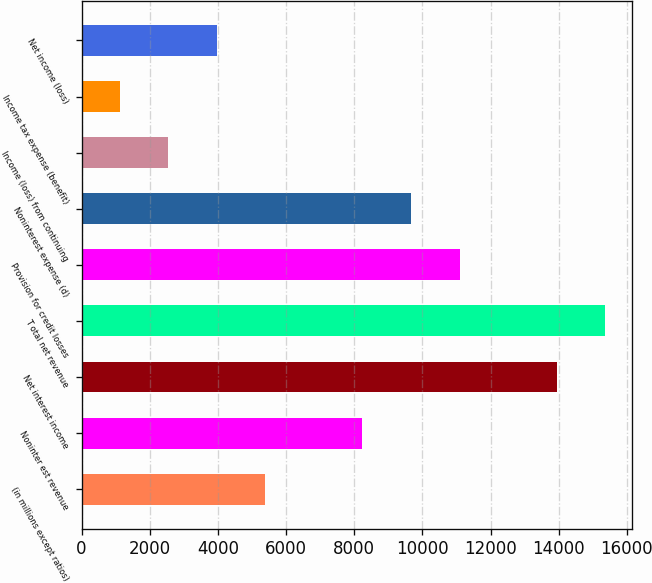Convert chart to OTSL. <chart><loc_0><loc_0><loc_500><loc_500><bar_chart><fcel>(in millions except ratios)<fcel>Noninter est revenue<fcel>Net interest income<fcel>T otal net revenue<fcel>Provision for credit losses<fcel>Noninterest expense (d)<fcel>Income (loss) from continuing<fcel>Income tax expense (benefit)<fcel>Net income (loss)<nl><fcel>5389.6<fcel>8240<fcel>13940.8<fcel>15366<fcel>11090.4<fcel>9665.2<fcel>2539.2<fcel>1114<fcel>3964.4<nl></chart> 